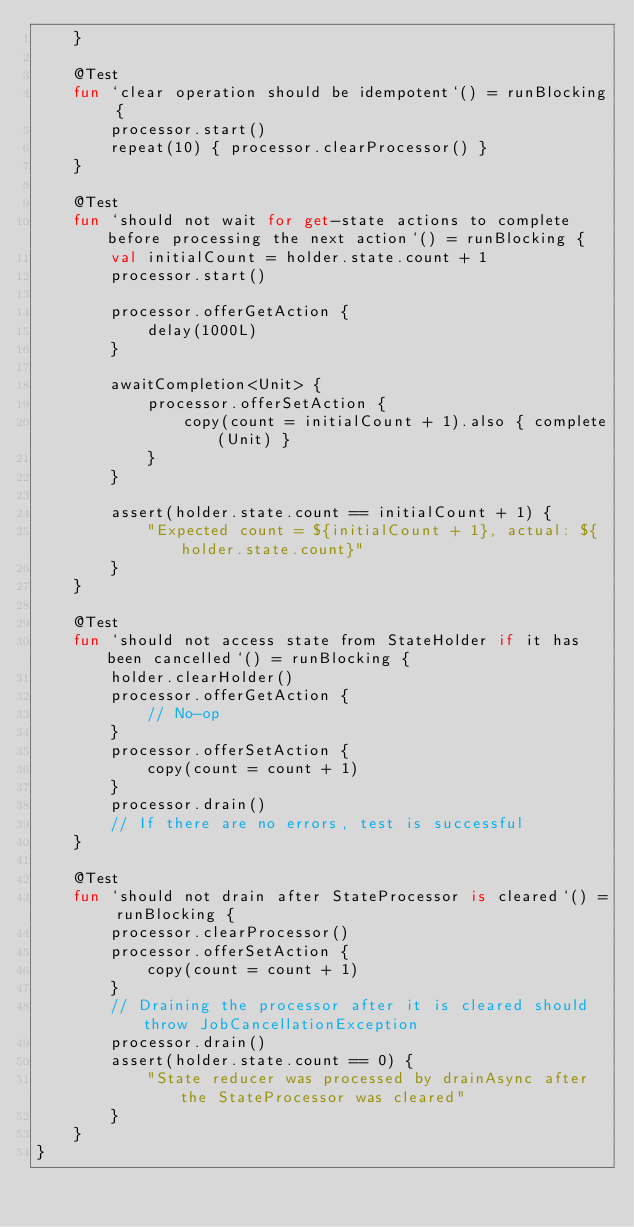<code> <loc_0><loc_0><loc_500><loc_500><_Kotlin_>    }

    @Test
    fun `clear operation should be idempotent`() = runBlocking {
        processor.start()
        repeat(10) { processor.clearProcessor() }
    }

    @Test
    fun `should not wait for get-state actions to complete before processing the next action`() = runBlocking {
        val initialCount = holder.state.count + 1
        processor.start()

        processor.offerGetAction {
            delay(1000L)
        }

        awaitCompletion<Unit> {
            processor.offerSetAction {
                copy(count = initialCount + 1).also { complete(Unit) }
            }
        }

        assert(holder.state.count == initialCount + 1) {
            "Expected count = ${initialCount + 1}, actual: ${holder.state.count}"
        }
    }

    @Test
    fun `should not access state from StateHolder if it has been cancelled`() = runBlocking {
        holder.clearHolder()
        processor.offerGetAction {
            // No-op
        }
        processor.offerSetAction {
            copy(count = count + 1)
        }
        processor.drain()
        // If there are no errors, test is successful
    }

    @Test
    fun `should not drain after StateProcessor is cleared`() = runBlocking {
        processor.clearProcessor()
        processor.offerSetAction {
            copy(count = count + 1)
        }
        // Draining the processor after it is cleared should throw JobCancellationException
        processor.drain()
        assert(holder.state.count == 0) {
            "State reducer was processed by drainAsync after the StateProcessor was cleared"
        }
    }
}</code> 